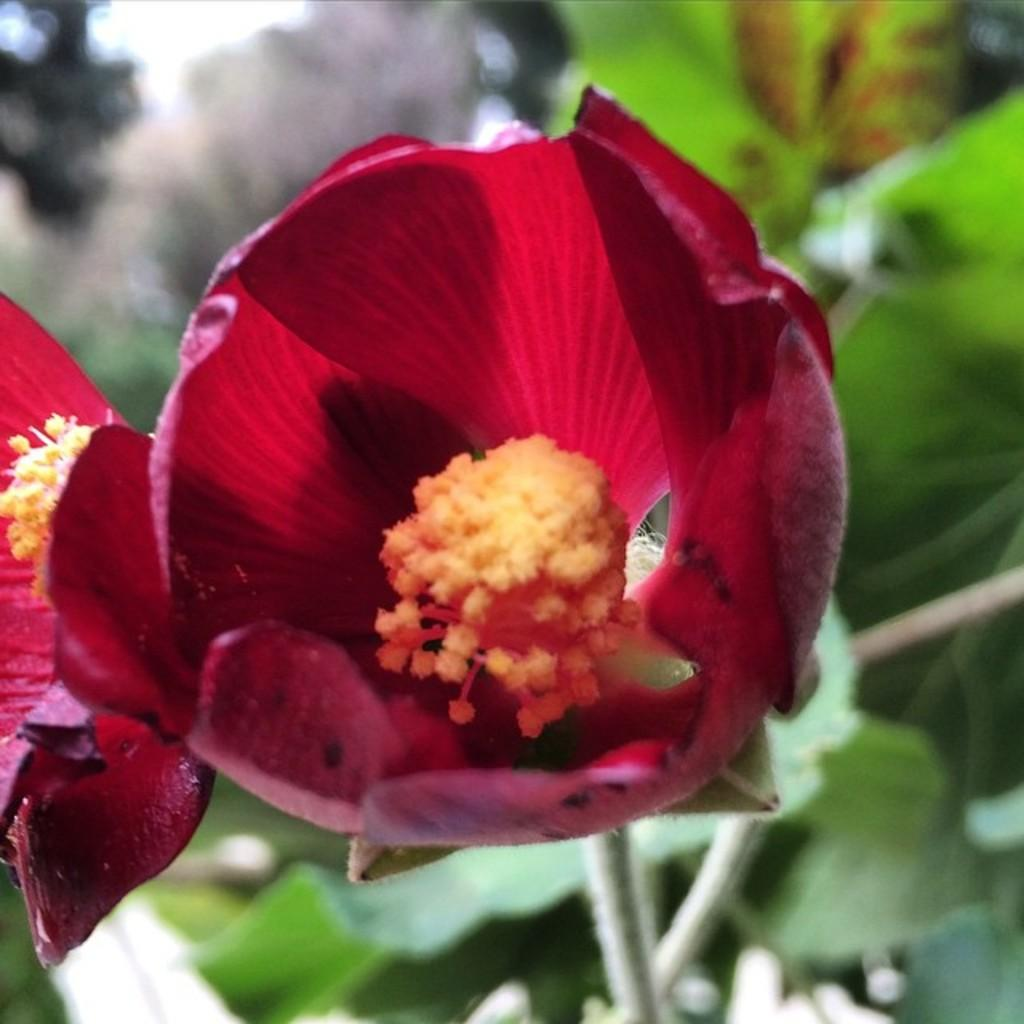What type of flower can be seen in the image? There is a red color flower in the image. What other plants are present in the image? There are plants on the right side of the image. Can you describe any specific part of a plant visible in the image? Yes, there is a leaf visible in the image. What hobbies are the flowers engaging in during the image? Flowers do not have hobbies, as they are inanimate objects. 